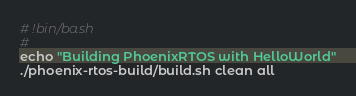Convert code to text. <code><loc_0><loc_0><loc_500><loc_500><_Bash_># !bin/bash
#
echo "Building PhoenixRTOS with HelloWorld"
./phoenix-rtos-build/build.sh clean all
</code> 